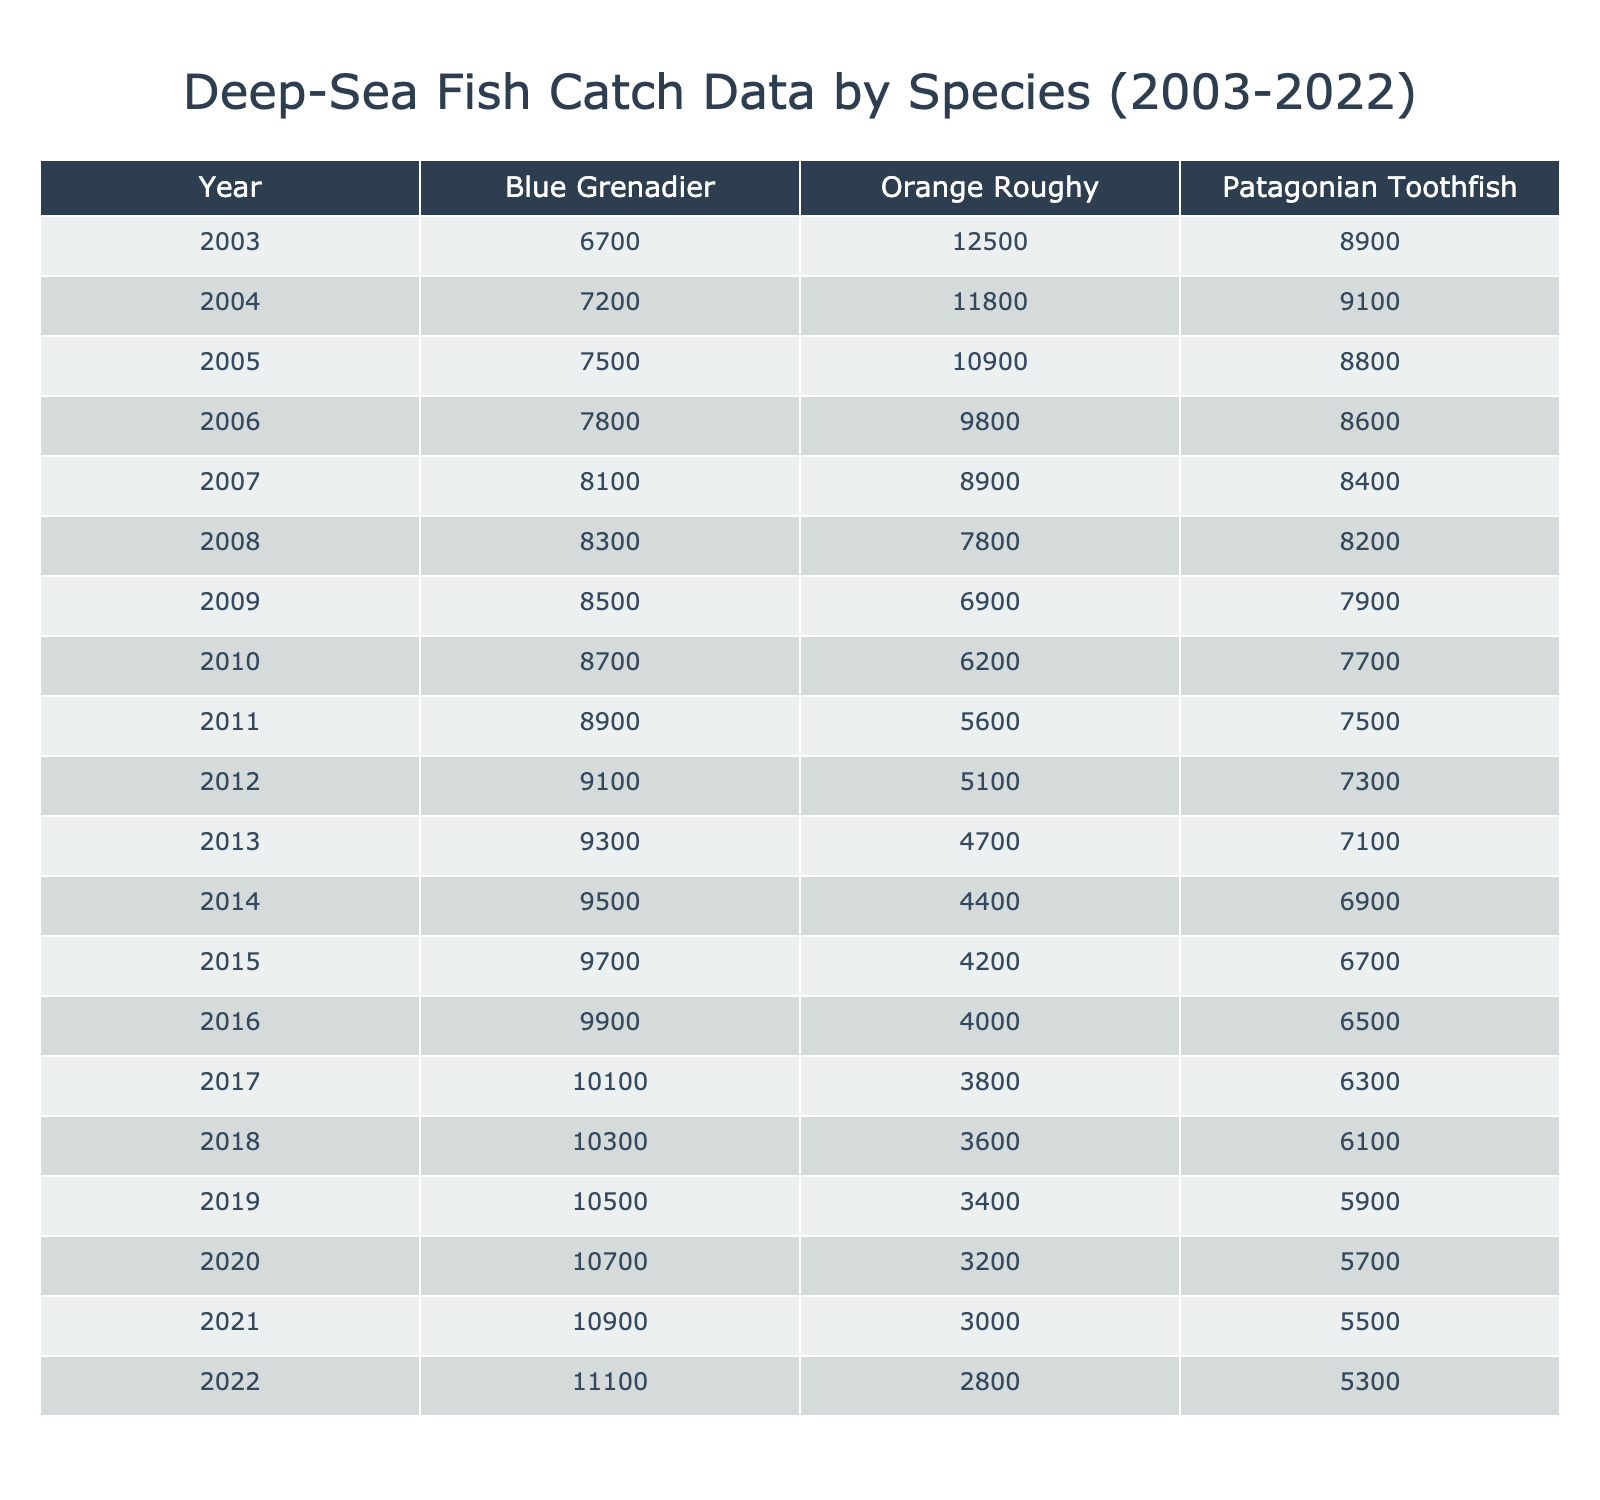What was the total catch of Blue Grenadier in 2020? Looking at the row for 2020, the catch for Blue Grenadier is listed as 10,700 tons.
Answer: 10,700 tons In which year did the Orange Roughy catch first fall below 4,000 tons? The data shows that Orange Roughy catches decreased year by year from 2003 to 2022. The catch first fell below 4,000 tons in 2019.
Answer: 2019 What is the average catch of Patagonian Toothfish over the last two decades? To find the average, I sum the catches from each year (8,900 + 9,100 + 8,800 + 8,600 + 8,400 + 8,200 + 7,900 + 7,700 + 7,500 + 7,300 + 7,100 + 6,900 + 6,700 + 6,500 + 6,300 + 6,100 + 5,900 + 5,700 + 5,500 + 5,300) which equals 137,100 tons. There are 20 data points, so I divide 137,100 by 20, resulting in an average of 6,855 tons.
Answer: 6,855 tons Did the total catch of Orange Roughy increase from 2003 to 2008? For Orange Roughy, the catches in these years are: 12,500 (2003), 11,800 (2004), 10,900 (2005), 9,800 (2006), 8,900 (2007), and 7,800 (2008). We can see that each following year shows a decrease, so the total catch did not increase.
Answer: No What was the decline in Blue Grenadier catch from 2003 to 2022? The catch value for Blue Grenadier in 2003 is 6,700 tons and in 2022 it is 11,100 tons. To find the decline, I compare the years, noting an actual increase of 4,400 tons from 6,700 to 11,100 instead of a decline. Hence there is no decline but an increase over this time frame.
Answer: No decline, an increase of 4,400 tons 